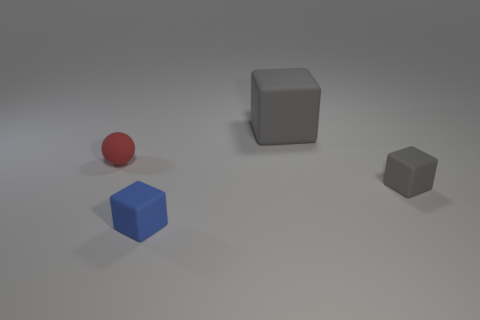Add 4 red rubber cylinders. How many objects exist? 8 Subtract all spheres. How many objects are left? 3 Subtract 0 gray cylinders. How many objects are left? 4 Subtract all tiny rubber balls. Subtract all tiny rubber spheres. How many objects are left? 2 Add 1 spheres. How many spheres are left? 2 Add 2 large gray matte cubes. How many large gray matte cubes exist? 3 